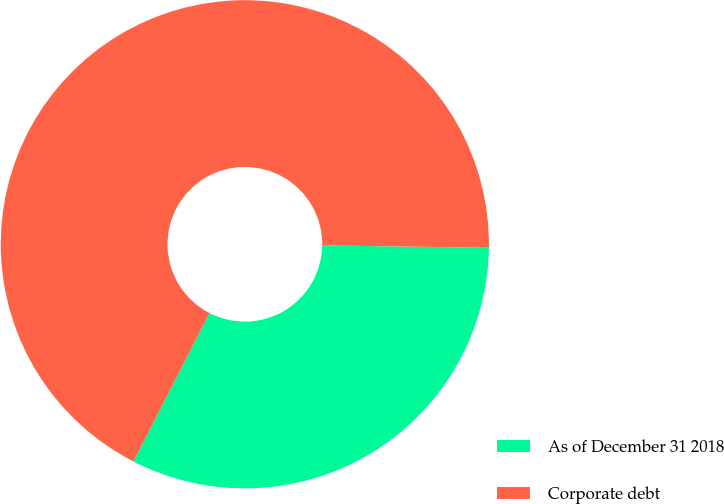Convert chart to OTSL. <chart><loc_0><loc_0><loc_500><loc_500><pie_chart><fcel>As of December 31 2018<fcel>Corporate debt<nl><fcel>32.32%<fcel>67.68%<nl></chart> 